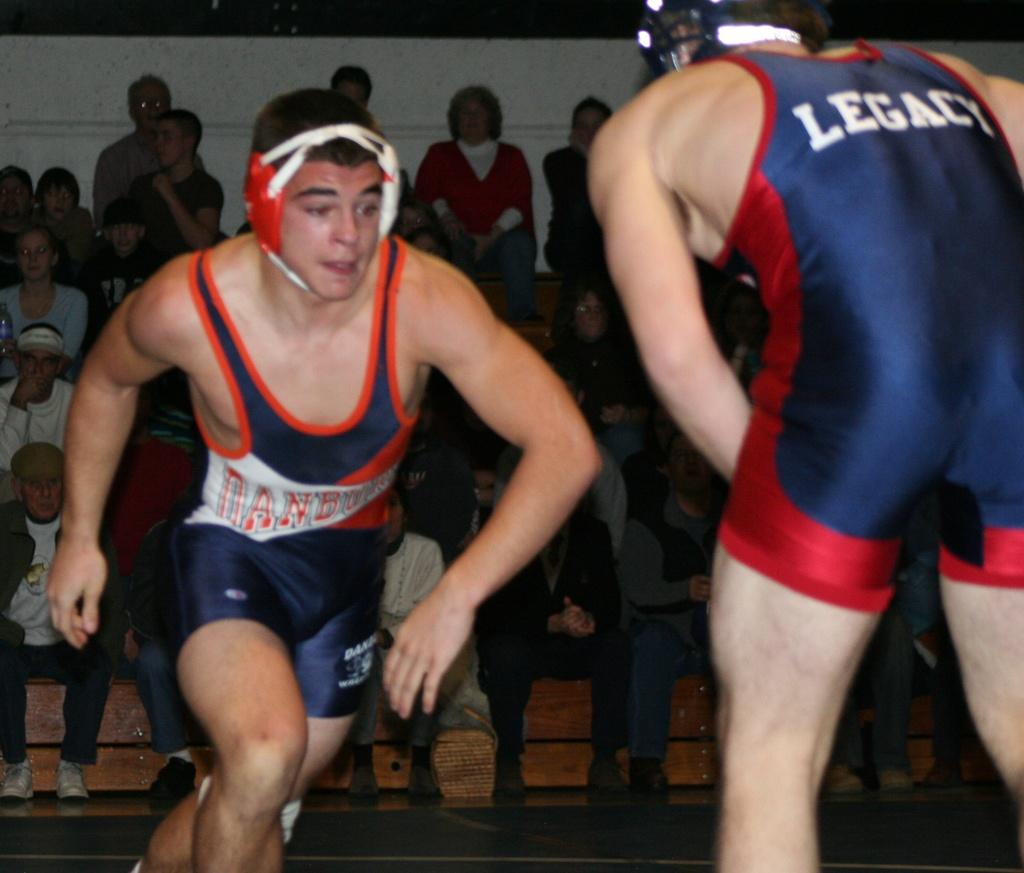<image>
Describe the image concisely. A wrestler from Legacy is beginning to start his match 